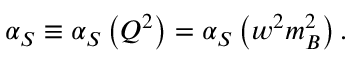<formula> <loc_0><loc_0><loc_500><loc_500>\alpha _ { S } \equiv \alpha _ { S } \left ( Q ^ { 2 } \right ) = \alpha _ { S } \left ( w ^ { 2 } m _ { B } ^ { 2 } \right ) .</formula> 